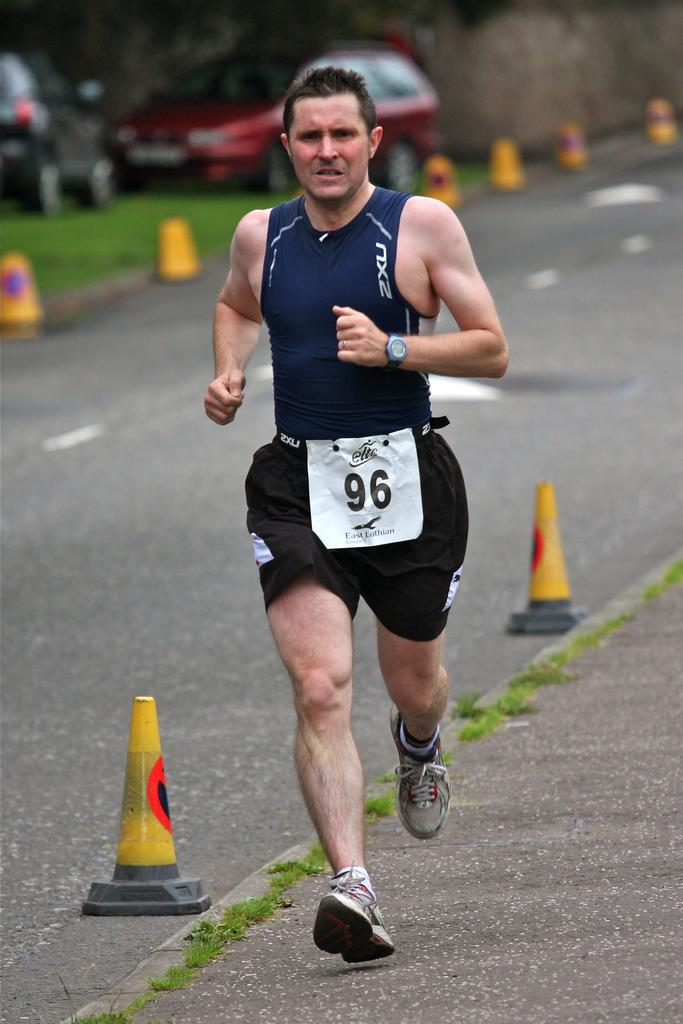What is the person in the image doing? The person is running in the image. What can be seen in the background of the image? There are stands with yellow color and cars visible in the background. What type of surface is the person running on? There is grass on the ground, so the person is running on grass. What other structures are present in the background? There is a wall in the background. What type of riddle is being solved by the person running in the image? There is no riddle present in the image; it simply shows a person running. Can you tell me what hospital the person is running towards in the image? There is no hospital visible in the image, nor is there any indication that the person is running towards one. 